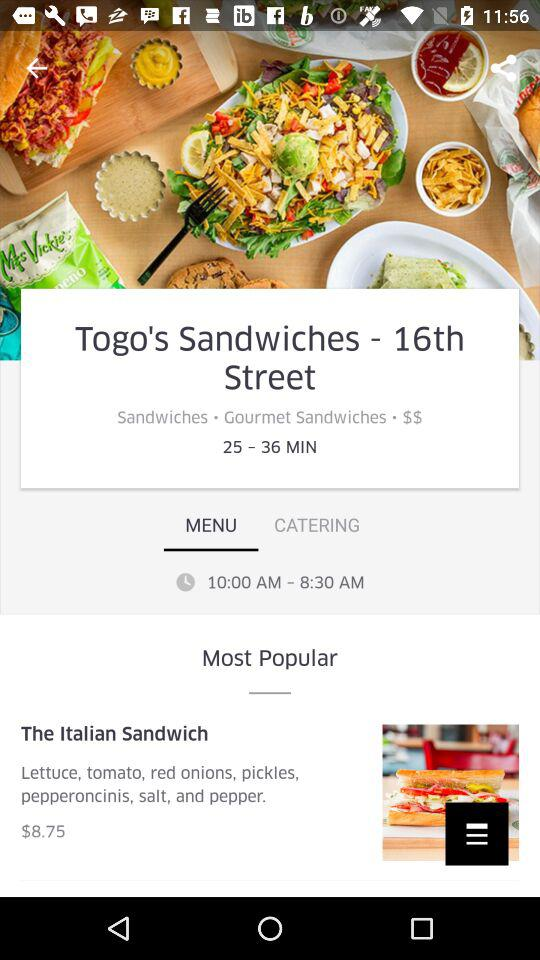What are the hours of "Togo's Sandwiches"? The hours of "Togo's Sandwiches" are from 10:00 AM to 8:30 AM. 